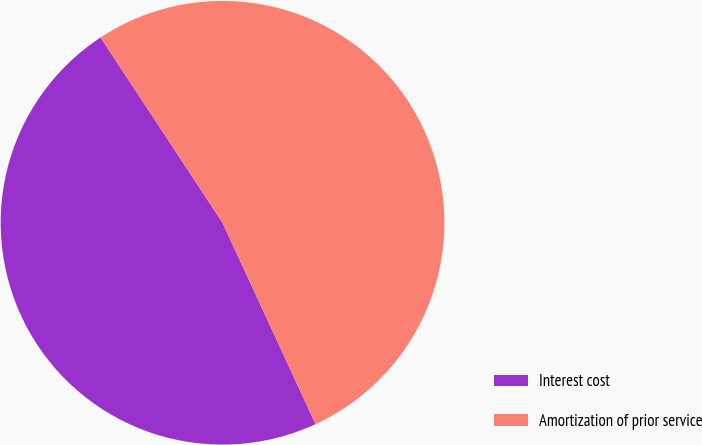Convert chart. <chart><loc_0><loc_0><loc_500><loc_500><pie_chart><fcel>Interest cost<fcel>Amortization of prior service<nl><fcel>47.62%<fcel>52.38%<nl></chart> 